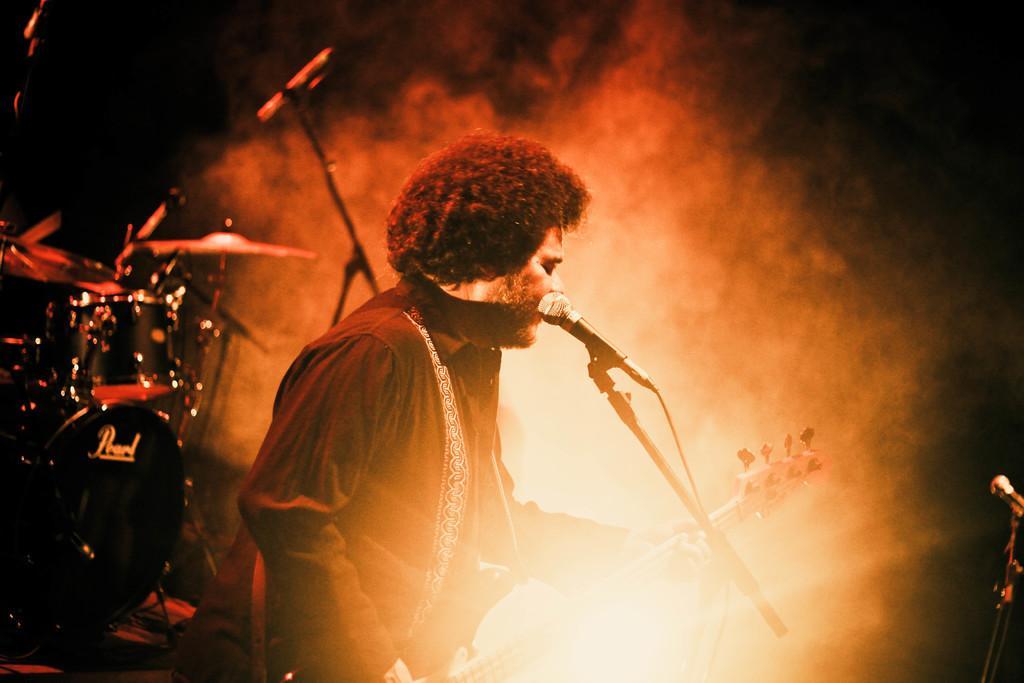In one or two sentences, can you explain what this image depicts? In this image in the foreground there is one man who is holding a guitar, and in front of him there is a mike. And in the background there are some drums and fog, on the right side there is a mike and there is a dark background. 